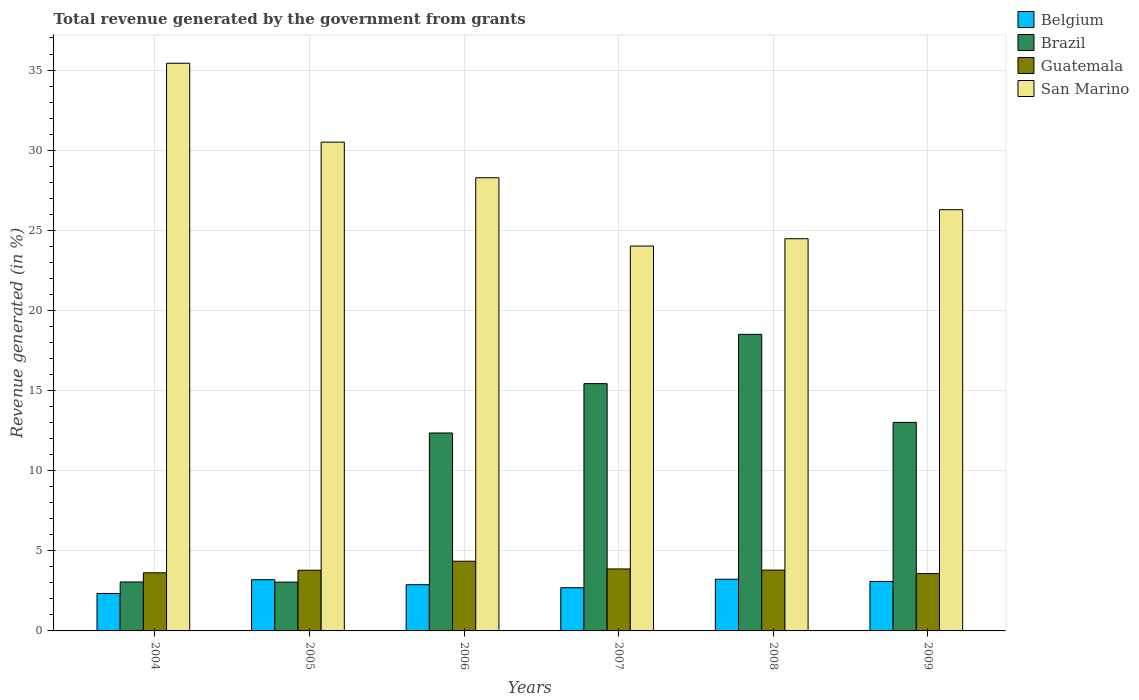How many different coloured bars are there?
Offer a very short reply. 4. Are the number of bars per tick equal to the number of legend labels?
Make the answer very short. Yes. How many bars are there on the 2nd tick from the left?
Your answer should be very brief. 4. How many bars are there on the 6th tick from the right?
Provide a short and direct response. 4. What is the label of the 6th group of bars from the left?
Your answer should be very brief. 2009. What is the total revenue generated in Brazil in 2007?
Give a very brief answer. 15.43. Across all years, what is the maximum total revenue generated in Belgium?
Make the answer very short. 3.23. Across all years, what is the minimum total revenue generated in Guatemala?
Offer a terse response. 3.58. In which year was the total revenue generated in Guatemala maximum?
Offer a very short reply. 2006. What is the total total revenue generated in Guatemala in the graph?
Your response must be concise. 23.01. What is the difference between the total revenue generated in San Marino in 2006 and that in 2008?
Your answer should be compact. 3.81. What is the difference between the total revenue generated in Belgium in 2007 and the total revenue generated in Brazil in 2008?
Offer a very short reply. -15.81. What is the average total revenue generated in Brazil per year?
Your answer should be compact. 10.9. In the year 2007, what is the difference between the total revenue generated in Guatemala and total revenue generated in Belgium?
Your answer should be compact. 1.17. In how many years, is the total revenue generated in San Marino greater than 5 %?
Provide a short and direct response. 6. What is the ratio of the total revenue generated in Belgium in 2008 to that in 2009?
Your response must be concise. 1.04. Is the difference between the total revenue generated in Guatemala in 2004 and 2008 greater than the difference between the total revenue generated in Belgium in 2004 and 2008?
Give a very brief answer. Yes. What is the difference between the highest and the second highest total revenue generated in San Marino?
Your answer should be compact. 4.92. What is the difference between the highest and the lowest total revenue generated in Brazil?
Give a very brief answer. 15.46. Is it the case that in every year, the sum of the total revenue generated in Brazil and total revenue generated in San Marino is greater than the sum of total revenue generated in Guatemala and total revenue generated in Belgium?
Your response must be concise. Yes. What does the 4th bar from the left in 2008 represents?
Offer a very short reply. San Marino. What does the 1st bar from the right in 2004 represents?
Offer a terse response. San Marino. Is it the case that in every year, the sum of the total revenue generated in Guatemala and total revenue generated in San Marino is greater than the total revenue generated in Belgium?
Offer a terse response. Yes. How many bars are there?
Give a very brief answer. 24. How many years are there in the graph?
Give a very brief answer. 6. What is the difference between two consecutive major ticks on the Y-axis?
Provide a short and direct response. 5. Does the graph contain grids?
Give a very brief answer. Yes. What is the title of the graph?
Give a very brief answer. Total revenue generated by the government from grants. Does "Sao Tome and Principe" appear as one of the legend labels in the graph?
Your answer should be compact. No. What is the label or title of the X-axis?
Offer a very short reply. Years. What is the label or title of the Y-axis?
Your answer should be compact. Revenue generated (in %). What is the Revenue generated (in %) in Belgium in 2004?
Offer a terse response. 2.34. What is the Revenue generated (in %) in Brazil in 2004?
Your response must be concise. 3.05. What is the Revenue generated (in %) of Guatemala in 2004?
Provide a short and direct response. 3.63. What is the Revenue generated (in %) of San Marino in 2004?
Make the answer very short. 35.42. What is the Revenue generated (in %) of Belgium in 2005?
Provide a short and direct response. 3.2. What is the Revenue generated (in %) in Brazil in 2005?
Your answer should be very brief. 3.04. What is the Revenue generated (in %) in Guatemala in 2005?
Offer a terse response. 3.79. What is the Revenue generated (in %) of San Marino in 2005?
Your answer should be very brief. 30.5. What is the Revenue generated (in %) in Belgium in 2006?
Make the answer very short. 2.88. What is the Revenue generated (in %) of Brazil in 2006?
Your response must be concise. 12.35. What is the Revenue generated (in %) of Guatemala in 2006?
Your response must be concise. 4.35. What is the Revenue generated (in %) of San Marino in 2006?
Your answer should be very brief. 28.28. What is the Revenue generated (in %) in Belgium in 2007?
Keep it short and to the point. 2.7. What is the Revenue generated (in %) in Brazil in 2007?
Keep it short and to the point. 15.43. What is the Revenue generated (in %) in Guatemala in 2007?
Provide a short and direct response. 3.87. What is the Revenue generated (in %) in San Marino in 2007?
Your answer should be compact. 24.02. What is the Revenue generated (in %) of Belgium in 2008?
Keep it short and to the point. 3.23. What is the Revenue generated (in %) in Brazil in 2008?
Give a very brief answer. 18.51. What is the Revenue generated (in %) in Guatemala in 2008?
Offer a terse response. 3.8. What is the Revenue generated (in %) in San Marino in 2008?
Your response must be concise. 24.47. What is the Revenue generated (in %) in Belgium in 2009?
Offer a very short reply. 3.09. What is the Revenue generated (in %) in Brazil in 2009?
Your response must be concise. 13.01. What is the Revenue generated (in %) of Guatemala in 2009?
Provide a short and direct response. 3.58. What is the Revenue generated (in %) of San Marino in 2009?
Provide a short and direct response. 26.28. Across all years, what is the maximum Revenue generated (in %) of Belgium?
Keep it short and to the point. 3.23. Across all years, what is the maximum Revenue generated (in %) of Brazil?
Your answer should be compact. 18.51. Across all years, what is the maximum Revenue generated (in %) in Guatemala?
Your response must be concise. 4.35. Across all years, what is the maximum Revenue generated (in %) in San Marino?
Provide a succinct answer. 35.42. Across all years, what is the minimum Revenue generated (in %) in Belgium?
Give a very brief answer. 2.34. Across all years, what is the minimum Revenue generated (in %) in Brazil?
Offer a terse response. 3.04. Across all years, what is the minimum Revenue generated (in %) of Guatemala?
Your answer should be compact. 3.58. Across all years, what is the minimum Revenue generated (in %) in San Marino?
Ensure brevity in your answer.  24.02. What is the total Revenue generated (in %) in Belgium in the graph?
Your answer should be very brief. 17.43. What is the total Revenue generated (in %) of Brazil in the graph?
Your response must be concise. 65.4. What is the total Revenue generated (in %) of Guatemala in the graph?
Your response must be concise. 23.01. What is the total Revenue generated (in %) of San Marino in the graph?
Make the answer very short. 168.98. What is the difference between the Revenue generated (in %) in Belgium in 2004 and that in 2005?
Provide a short and direct response. -0.86. What is the difference between the Revenue generated (in %) in Brazil in 2004 and that in 2005?
Give a very brief answer. 0.01. What is the difference between the Revenue generated (in %) in Guatemala in 2004 and that in 2005?
Your answer should be compact. -0.16. What is the difference between the Revenue generated (in %) of San Marino in 2004 and that in 2005?
Provide a succinct answer. 4.92. What is the difference between the Revenue generated (in %) of Belgium in 2004 and that in 2006?
Provide a succinct answer. -0.55. What is the difference between the Revenue generated (in %) of Brazil in 2004 and that in 2006?
Give a very brief answer. -9.3. What is the difference between the Revenue generated (in %) of Guatemala in 2004 and that in 2006?
Provide a short and direct response. -0.72. What is the difference between the Revenue generated (in %) in San Marino in 2004 and that in 2006?
Ensure brevity in your answer.  7.14. What is the difference between the Revenue generated (in %) in Belgium in 2004 and that in 2007?
Offer a very short reply. -0.36. What is the difference between the Revenue generated (in %) of Brazil in 2004 and that in 2007?
Your answer should be compact. -12.38. What is the difference between the Revenue generated (in %) of Guatemala in 2004 and that in 2007?
Make the answer very short. -0.24. What is the difference between the Revenue generated (in %) in San Marino in 2004 and that in 2007?
Your response must be concise. 11.41. What is the difference between the Revenue generated (in %) of Belgium in 2004 and that in 2008?
Provide a short and direct response. -0.89. What is the difference between the Revenue generated (in %) in Brazil in 2004 and that in 2008?
Your answer should be compact. -15.45. What is the difference between the Revenue generated (in %) in Guatemala in 2004 and that in 2008?
Your answer should be very brief. -0.17. What is the difference between the Revenue generated (in %) in San Marino in 2004 and that in 2008?
Make the answer very short. 10.95. What is the difference between the Revenue generated (in %) in Belgium in 2004 and that in 2009?
Keep it short and to the point. -0.75. What is the difference between the Revenue generated (in %) in Brazil in 2004 and that in 2009?
Ensure brevity in your answer.  -9.96. What is the difference between the Revenue generated (in %) in Guatemala in 2004 and that in 2009?
Your answer should be very brief. 0.05. What is the difference between the Revenue generated (in %) in San Marino in 2004 and that in 2009?
Give a very brief answer. 9.14. What is the difference between the Revenue generated (in %) of Belgium in 2005 and that in 2006?
Offer a very short reply. 0.31. What is the difference between the Revenue generated (in %) of Brazil in 2005 and that in 2006?
Provide a succinct answer. -9.31. What is the difference between the Revenue generated (in %) of Guatemala in 2005 and that in 2006?
Your answer should be very brief. -0.56. What is the difference between the Revenue generated (in %) of San Marino in 2005 and that in 2006?
Keep it short and to the point. 2.22. What is the difference between the Revenue generated (in %) in Belgium in 2005 and that in 2007?
Provide a succinct answer. 0.5. What is the difference between the Revenue generated (in %) of Brazil in 2005 and that in 2007?
Your response must be concise. -12.39. What is the difference between the Revenue generated (in %) in Guatemala in 2005 and that in 2007?
Your response must be concise. -0.08. What is the difference between the Revenue generated (in %) of San Marino in 2005 and that in 2007?
Ensure brevity in your answer.  6.49. What is the difference between the Revenue generated (in %) of Belgium in 2005 and that in 2008?
Provide a succinct answer. -0.03. What is the difference between the Revenue generated (in %) of Brazil in 2005 and that in 2008?
Your answer should be very brief. -15.46. What is the difference between the Revenue generated (in %) of Guatemala in 2005 and that in 2008?
Provide a succinct answer. -0.01. What is the difference between the Revenue generated (in %) in San Marino in 2005 and that in 2008?
Make the answer very short. 6.03. What is the difference between the Revenue generated (in %) in Belgium in 2005 and that in 2009?
Ensure brevity in your answer.  0.11. What is the difference between the Revenue generated (in %) in Brazil in 2005 and that in 2009?
Offer a very short reply. -9.97. What is the difference between the Revenue generated (in %) of Guatemala in 2005 and that in 2009?
Offer a terse response. 0.21. What is the difference between the Revenue generated (in %) of San Marino in 2005 and that in 2009?
Keep it short and to the point. 4.22. What is the difference between the Revenue generated (in %) of Belgium in 2006 and that in 2007?
Your answer should be very brief. 0.19. What is the difference between the Revenue generated (in %) in Brazil in 2006 and that in 2007?
Provide a succinct answer. -3.08. What is the difference between the Revenue generated (in %) in Guatemala in 2006 and that in 2007?
Provide a succinct answer. 0.48. What is the difference between the Revenue generated (in %) in San Marino in 2006 and that in 2007?
Make the answer very short. 4.26. What is the difference between the Revenue generated (in %) in Belgium in 2006 and that in 2008?
Your answer should be compact. -0.34. What is the difference between the Revenue generated (in %) in Brazil in 2006 and that in 2008?
Your answer should be very brief. -6.16. What is the difference between the Revenue generated (in %) of Guatemala in 2006 and that in 2008?
Provide a succinct answer. 0.55. What is the difference between the Revenue generated (in %) of San Marino in 2006 and that in 2008?
Provide a succinct answer. 3.81. What is the difference between the Revenue generated (in %) of Belgium in 2006 and that in 2009?
Your answer should be very brief. -0.2. What is the difference between the Revenue generated (in %) in Brazil in 2006 and that in 2009?
Keep it short and to the point. -0.66. What is the difference between the Revenue generated (in %) in Guatemala in 2006 and that in 2009?
Your answer should be very brief. 0.77. What is the difference between the Revenue generated (in %) in San Marino in 2006 and that in 2009?
Your answer should be compact. 1.99. What is the difference between the Revenue generated (in %) of Belgium in 2007 and that in 2008?
Provide a short and direct response. -0.53. What is the difference between the Revenue generated (in %) in Brazil in 2007 and that in 2008?
Your response must be concise. -3.08. What is the difference between the Revenue generated (in %) in Guatemala in 2007 and that in 2008?
Provide a succinct answer. 0.07. What is the difference between the Revenue generated (in %) in San Marino in 2007 and that in 2008?
Give a very brief answer. -0.46. What is the difference between the Revenue generated (in %) of Belgium in 2007 and that in 2009?
Ensure brevity in your answer.  -0.39. What is the difference between the Revenue generated (in %) of Brazil in 2007 and that in 2009?
Your answer should be compact. 2.42. What is the difference between the Revenue generated (in %) in Guatemala in 2007 and that in 2009?
Offer a very short reply. 0.29. What is the difference between the Revenue generated (in %) of San Marino in 2007 and that in 2009?
Offer a terse response. -2.27. What is the difference between the Revenue generated (in %) of Belgium in 2008 and that in 2009?
Ensure brevity in your answer.  0.14. What is the difference between the Revenue generated (in %) of Brazil in 2008 and that in 2009?
Your response must be concise. 5.5. What is the difference between the Revenue generated (in %) of Guatemala in 2008 and that in 2009?
Provide a succinct answer. 0.22. What is the difference between the Revenue generated (in %) of San Marino in 2008 and that in 2009?
Offer a terse response. -1.81. What is the difference between the Revenue generated (in %) in Belgium in 2004 and the Revenue generated (in %) in Brazil in 2005?
Give a very brief answer. -0.71. What is the difference between the Revenue generated (in %) in Belgium in 2004 and the Revenue generated (in %) in Guatemala in 2005?
Make the answer very short. -1.45. What is the difference between the Revenue generated (in %) of Belgium in 2004 and the Revenue generated (in %) of San Marino in 2005?
Make the answer very short. -28.16. What is the difference between the Revenue generated (in %) in Brazil in 2004 and the Revenue generated (in %) in Guatemala in 2005?
Your response must be concise. -0.73. What is the difference between the Revenue generated (in %) in Brazil in 2004 and the Revenue generated (in %) in San Marino in 2005?
Give a very brief answer. -27.45. What is the difference between the Revenue generated (in %) of Guatemala in 2004 and the Revenue generated (in %) of San Marino in 2005?
Offer a very short reply. -26.87. What is the difference between the Revenue generated (in %) in Belgium in 2004 and the Revenue generated (in %) in Brazil in 2006?
Provide a succinct answer. -10.01. What is the difference between the Revenue generated (in %) in Belgium in 2004 and the Revenue generated (in %) in Guatemala in 2006?
Keep it short and to the point. -2.01. What is the difference between the Revenue generated (in %) in Belgium in 2004 and the Revenue generated (in %) in San Marino in 2006?
Offer a very short reply. -25.94. What is the difference between the Revenue generated (in %) of Brazil in 2004 and the Revenue generated (in %) of Guatemala in 2006?
Your answer should be compact. -1.3. What is the difference between the Revenue generated (in %) of Brazil in 2004 and the Revenue generated (in %) of San Marino in 2006?
Give a very brief answer. -25.22. What is the difference between the Revenue generated (in %) of Guatemala in 2004 and the Revenue generated (in %) of San Marino in 2006?
Offer a very short reply. -24.65. What is the difference between the Revenue generated (in %) of Belgium in 2004 and the Revenue generated (in %) of Brazil in 2007?
Your response must be concise. -13.09. What is the difference between the Revenue generated (in %) in Belgium in 2004 and the Revenue generated (in %) in Guatemala in 2007?
Your answer should be compact. -1.53. What is the difference between the Revenue generated (in %) of Belgium in 2004 and the Revenue generated (in %) of San Marino in 2007?
Offer a terse response. -21.68. What is the difference between the Revenue generated (in %) in Brazil in 2004 and the Revenue generated (in %) in Guatemala in 2007?
Make the answer very short. -0.81. What is the difference between the Revenue generated (in %) in Brazil in 2004 and the Revenue generated (in %) in San Marino in 2007?
Ensure brevity in your answer.  -20.96. What is the difference between the Revenue generated (in %) in Guatemala in 2004 and the Revenue generated (in %) in San Marino in 2007?
Provide a succinct answer. -20.39. What is the difference between the Revenue generated (in %) of Belgium in 2004 and the Revenue generated (in %) of Brazil in 2008?
Your response must be concise. -16.17. What is the difference between the Revenue generated (in %) in Belgium in 2004 and the Revenue generated (in %) in Guatemala in 2008?
Offer a very short reply. -1.46. What is the difference between the Revenue generated (in %) in Belgium in 2004 and the Revenue generated (in %) in San Marino in 2008?
Ensure brevity in your answer.  -22.14. What is the difference between the Revenue generated (in %) in Brazil in 2004 and the Revenue generated (in %) in Guatemala in 2008?
Give a very brief answer. -0.74. What is the difference between the Revenue generated (in %) of Brazil in 2004 and the Revenue generated (in %) of San Marino in 2008?
Your answer should be very brief. -21.42. What is the difference between the Revenue generated (in %) of Guatemala in 2004 and the Revenue generated (in %) of San Marino in 2008?
Provide a succinct answer. -20.85. What is the difference between the Revenue generated (in %) of Belgium in 2004 and the Revenue generated (in %) of Brazil in 2009?
Make the answer very short. -10.68. What is the difference between the Revenue generated (in %) in Belgium in 2004 and the Revenue generated (in %) in Guatemala in 2009?
Provide a short and direct response. -1.24. What is the difference between the Revenue generated (in %) of Belgium in 2004 and the Revenue generated (in %) of San Marino in 2009?
Your answer should be very brief. -23.95. What is the difference between the Revenue generated (in %) of Brazil in 2004 and the Revenue generated (in %) of Guatemala in 2009?
Make the answer very short. -0.53. What is the difference between the Revenue generated (in %) of Brazil in 2004 and the Revenue generated (in %) of San Marino in 2009?
Your answer should be compact. -23.23. What is the difference between the Revenue generated (in %) of Guatemala in 2004 and the Revenue generated (in %) of San Marino in 2009?
Provide a succinct answer. -22.66. What is the difference between the Revenue generated (in %) of Belgium in 2005 and the Revenue generated (in %) of Brazil in 2006?
Provide a succinct answer. -9.15. What is the difference between the Revenue generated (in %) of Belgium in 2005 and the Revenue generated (in %) of Guatemala in 2006?
Keep it short and to the point. -1.15. What is the difference between the Revenue generated (in %) in Belgium in 2005 and the Revenue generated (in %) in San Marino in 2006?
Offer a very short reply. -25.08. What is the difference between the Revenue generated (in %) of Brazil in 2005 and the Revenue generated (in %) of Guatemala in 2006?
Keep it short and to the point. -1.31. What is the difference between the Revenue generated (in %) in Brazil in 2005 and the Revenue generated (in %) in San Marino in 2006?
Make the answer very short. -25.23. What is the difference between the Revenue generated (in %) in Guatemala in 2005 and the Revenue generated (in %) in San Marino in 2006?
Ensure brevity in your answer.  -24.49. What is the difference between the Revenue generated (in %) of Belgium in 2005 and the Revenue generated (in %) of Brazil in 2007?
Provide a succinct answer. -12.23. What is the difference between the Revenue generated (in %) of Belgium in 2005 and the Revenue generated (in %) of Guatemala in 2007?
Your answer should be compact. -0.67. What is the difference between the Revenue generated (in %) of Belgium in 2005 and the Revenue generated (in %) of San Marino in 2007?
Make the answer very short. -20.82. What is the difference between the Revenue generated (in %) of Brazil in 2005 and the Revenue generated (in %) of Guatemala in 2007?
Your answer should be compact. -0.82. What is the difference between the Revenue generated (in %) in Brazil in 2005 and the Revenue generated (in %) in San Marino in 2007?
Provide a succinct answer. -20.97. What is the difference between the Revenue generated (in %) in Guatemala in 2005 and the Revenue generated (in %) in San Marino in 2007?
Your response must be concise. -20.23. What is the difference between the Revenue generated (in %) of Belgium in 2005 and the Revenue generated (in %) of Brazil in 2008?
Keep it short and to the point. -15.31. What is the difference between the Revenue generated (in %) in Belgium in 2005 and the Revenue generated (in %) in Guatemala in 2008?
Your response must be concise. -0.6. What is the difference between the Revenue generated (in %) of Belgium in 2005 and the Revenue generated (in %) of San Marino in 2008?
Make the answer very short. -21.28. What is the difference between the Revenue generated (in %) in Brazil in 2005 and the Revenue generated (in %) in Guatemala in 2008?
Ensure brevity in your answer.  -0.75. What is the difference between the Revenue generated (in %) of Brazil in 2005 and the Revenue generated (in %) of San Marino in 2008?
Provide a short and direct response. -21.43. What is the difference between the Revenue generated (in %) of Guatemala in 2005 and the Revenue generated (in %) of San Marino in 2008?
Offer a terse response. -20.69. What is the difference between the Revenue generated (in %) of Belgium in 2005 and the Revenue generated (in %) of Brazil in 2009?
Offer a very short reply. -9.82. What is the difference between the Revenue generated (in %) in Belgium in 2005 and the Revenue generated (in %) in Guatemala in 2009?
Your answer should be compact. -0.38. What is the difference between the Revenue generated (in %) in Belgium in 2005 and the Revenue generated (in %) in San Marino in 2009?
Offer a terse response. -23.09. What is the difference between the Revenue generated (in %) of Brazil in 2005 and the Revenue generated (in %) of Guatemala in 2009?
Provide a short and direct response. -0.54. What is the difference between the Revenue generated (in %) in Brazil in 2005 and the Revenue generated (in %) in San Marino in 2009?
Offer a terse response. -23.24. What is the difference between the Revenue generated (in %) of Guatemala in 2005 and the Revenue generated (in %) of San Marino in 2009?
Make the answer very short. -22.5. What is the difference between the Revenue generated (in %) of Belgium in 2006 and the Revenue generated (in %) of Brazil in 2007?
Provide a short and direct response. -12.55. What is the difference between the Revenue generated (in %) of Belgium in 2006 and the Revenue generated (in %) of Guatemala in 2007?
Give a very brief answer. -0.98. What is the difference between the Revenue generated (in %) of Belgium in 2006 and the Revenue generated (in %) of San Marino in 2007?
Provide a short and direct response. -21.13. What is the difference between the Revenue generated (in %) of Brazil in 2006 and the Revenue generated (in %) of Guatemala in 2007?
Provide a short and direct response. 8.48. What is the difference between the Revenue generated (in %) of Brazil in 2006 and the Revenue generated (in %) of San Marino in 2007?
Offer a terse response. -11.66. What is the difference between the Revenue generated (in %) in Guatemala in 2006 and the Revenue generated (in %) in San Marino in 2007?
Your answer should be compact. -19.67. What is the difference between the Revenue generated (in %) of Belgium in 2006 and the Revenue generated (in %) of Brazil in 2008?
Your answer should be compact. -15.62. What is the difference between the Revenue generated (in %) in Belgium in 2006 and the Revenue generated (in %) in Guatemala in 2008?
Keep it short and to the point. -0.91. What is the difference between the Revenue generated (in %) in Belgium in 2006 and the Revenue generated (in %) in San Marino in 2008?
Give a very brief answer. -21.59. What is the difference between the Revenue generated (in %) of Brazil in 2006 and the Revenue generated (in %) of Guatemala in 2008?
Provide a succinct answer. 8.55. What is the difference between the Revenue generated (in %) of Brazil in 2006 and the Revenue generated (in %) of San Marino in 2008?
Offer a terse response. -12.12. What is the difference between the Revenue generated (in %) in Guatemala in 2006 and the Revenue generated (in %) in San Marino in 2008?
Offer a terse response. -20.12. What is the difference between the Revenue generated (in %) of Belgium in 2006 and the Revenue generated (in %) of Brazil in 2009?
Offer a terse response. -10.13. What is the difference between the Revenue generated (in %) in Belgium in 2006 and the Revenue generated (in %) in Guatemala in 2009?
Offer a very short reply. -0.7. What is the difference between the Revenue generated (in %) of Belgium in 2006 and the Revenue generated (in %) of San Marino in 2009?
Your answer should be compact. -23.4. What is the difference between the Revenue generated (in %) of Brazil in 2006 and the Revenue generated (in %) of Guatemala in 2009?
Your answer should be compact. 8.77. What is the difference between the Revenue generated (in %) in Brazil in 2006 and the Revenue generated (in %) in San Marino in 2009?
Your answer should be compact. -13.93. What is the difference between the Revenue generated (in %) in Guatemala in 2006 and the Revenue generated (in %) in San Marino in 2009?
Offer a terse response. -21.94. What is the difference between the Revenue generated (in %) in Belgium in 2007 and the Revenue generated (in %) in Brazil in 2008?
Give a very brief answer. -15.81. What is the difference between the Revenue generated (in %) in Belgium in 2007 and the Revenue generated (in %) in Guatemala in 2008?
Make the answer very short. -1.1. What is the difference between the Revenue generated (in %) in Belgium in 2007 and the Revenue generated (in %) in San Marino in 2008?
Provide a succinct answer. -21.78. What is the difference between the Revenue generated (in %) of Brazil in 2007 and the Revenue generated (in %) of Guatemala in 2008?
Provide a short and direct response. 11.63. What is the difference between the Revenue generated (in %) in Brazil in 2007 and the Revenue generated (in %) in San Marino in 2008?
Offer a very short reply. -9.04. What is the difference between the Revenue generated (in %) in Guatemala in 2007 and the Revenue generated (in %) in San Marino in 2008?
Provide a short and direct response. -20.61. What is the difference between the Revenue generated (in %) in Belgium in 2007 and the Revenue generated (in %) in Brazil in 2009?
Provide a short and direct response. -10.32. What is the difference between the Revenue generated (in %) in Belgium in 2007 and the Revenue generated (in %) in Guatemala in 2009?
Ensure brevity in your answer.  -0.88. What is the difference between the Revenue generated (in %) of Belgium in 2007 and the Revenue generated (in %) of San Marino in 2009?
Provide a short and direct response. -23.59. What is the difference between the Revenue generated (in %) in Brazil in 2007 and the Revenue generated (in %) in Guatemala in 2009?
Your response must be concise. 11.85. What is the difference between the Revenue generated (in %) in Brazil in 2007 and the Revenue generated (in %) in San Marino in 2009?
Your response must be concise. -10.85. What is the difference between the Revenue generated (in %) in Guatemala in 2007 and the Revenue generated (in %) in San Marino in 2009?
Provide a succinct answer. -22.42. What is the difference between the Revenue generated (in %) of Belgium in 2008 and the Revenue generated (in %) of Brazil in 2009?
Your answer should be compact. -9.79. What is the difference between the Revenue generated (in %) in Belgium in 2008 and the Revenue generated (in %) in Guatemala in 2009?
Make the answer very short. -0.35. What is the difference between the Revenue generated (in %) in Belgium in 2008 and the Revenue generated (in %) in San Marino in 2009?
Your answer should be compact. -23.06. What is the difference between the Revenue generated (in %) of Brazil in 2008 and the Revenue generated (in %) of Guatemala in 2009?
Keep it short and to the point. 14.93. What is the difference between the Revenue generated (in %) in Brazil in 2008 and the Revenue generated (in %) in San Marino in 2009?
Keep it short and to the point. -7.78. What is the difference between the Revenue generated (in %) of Guatemala in 2008 and the Revenue generated (in %) of San Marino in 2009?
Provide a succinct answer. -22.49. What is the average Revenue generated (in %) of Belgium per year?
Your answer should be compact. 2.9. What is the average Revenue generated (in %) in Brazil per year?
Offer a very short reply. 10.9. What is the average Revenue generated (in %) in Guatemala per year?
Your response must be concise. 3.83. What is the average Revenue generated (in %) of San Marino per year?
Ensure brevity in your answer.  28.16. In the year 2004, what is the difference between the Revenue generated (in %) of Belgium and Revenue generated (in %) of Brazil?
Give a very brief answer. -0.72. In the year 2004, what is the difference between the Revenue generated (in %) of Belgium and Revenue generated (in %) of Guatemala?
Give a very brief answer. -1.29. In the year 2004, what is the difference between the Revenue generated (in %) of Belgium and Revenue generated (in %) of San Marino?
Offer a very short reply. -33.09. In the year 2004, what is the difference between the Revenue generated (in %) in Brazil and Revenue generated (in %) in Guatemala?
Ensure brevity in your answer.  -0.57. In the year 2004, what is the difference between the Revenue generated (in %) of Brazil and Revenue generated (in %) of San Marino?
Keep it short and to the point. -32.37. In the year 2004, what is the difference between the Revenue generated (in %) of Guatemala and Revenue generated (in %) of San Marino?
Your answer should be very brief. -31.8. In the year 2005, what is the difference between the Revenue generated (in %) of Belgium and Revenue generated (in %) of Brazil?
Your response must be concise. 0.15. In the year 2005, what is the difference between the Revenue generated (in %) of Belgium and Revenue generated (in %) of Guatemala?
Provide a succinct answer. -0.59. In the year 2005, what is the difference between the Revenue generated (in %) in Belgium and Revenue generated (in %) in San Marino?
Offer a very short reply. -27.3. In the year 2005, what is the difference between the Revenue generated (in %) of Brazil and Revenue generated (in %) of Guatemala?
Your answer should be compact. -0.74. In the year 2005, what is the difference between the Revenue generated (in %) in Brazil and Revenue generated (in %) in San Marino?
Offer a very short reply. -27.46. In the year 2005, what is the difference between the Revenue generated (in %) of Guatemala and Revenue generated (in %) of San Marino?
Your response must be concise. -26.71. In the year 2006, what is the difference between the Revenue generated (in %) in Belgium and Revenue generated (in %) in Brazil?
Your response must be concise. -9.47. In the year 2006, what is the difference between the Revenue generated (in %) in Belgium and Revenue generated (in %) in Guatemala?
Provide a succinct answer. -1.47. In the year 2006, what is the difference between the Revenue generated (in %) in Belgium and Revenue generated (in %) in San Marino?
Provide a succinct answer. -25.39. In the year 2006, what is the difference between the Revenue generated (in %) in Brazil and Revenue generated (in %) in Guatemala?
Provide a short and direct response. 8. In the year 2006, what is the difference between the Revenue generated (in %) in Brazil and Revenue generated (in %) in San Marino?
Ensure brevity in your answer.  -15.93. In the year 2006, what is the difference between the Revenue generated (in %) in Guatemala and Revenue generated (in %) in San Marino?
Your answer should be very brief. -23.93. In the year 2007, what is the difference between the Revenue generated (in %) of Belgium and Revenue generated (in %) of Brazil?
Your response must be concise. -12.74. In the year 2007, what is the difference between the Revenue generated (in %) in Belgium and Revenue generated (in %) in Guatemala?
Your response must be concise. -1.17. In the year 2007, what is the difference between the Revenue generated (in %) in Belgium and Revenue generated (in %) in San Marino?
Make the answer very short. -21.32. In the year 2007, what is the difference between the Revenue generated (in %) in Brazil and Revenue generated (in %) in Guatemala?
Your answer should be very brief. 11.56. In the year 2007, what is the difference between the Revenue generated (in %) of Brazil and Revenue generated (in %) of San Marino?
Your answer should be very brief. -8.58. In the year 2007, what is the difference between the Revenue generated (in %) in Guatemala and Revenue generated (in %) in San Marino?
Your answer should be compact. -20.15. In the year 2008, what is the difference between the Revenue generated (in %) in Belgium and Revenue generated (in %) in Brazil?
Your answer should be very brief. -15.28. In the year 2008, what is the difference between the Revenue generated (in %) of Belgium and Revenue generated (in %) of Guatemala?
Keep it short and to the point. -0.57. In the year 2008, what is the difference between the Revenue generated (in %) of Belgium and Revenue generated (in %) of San Marino?
Offer a very short reply. -21.25. In the year 2008, what is the difference between the Revenue generated (in %) in Brazil and Revenue generated (in %) in Guatemala?
Keep it short and to the point. 14.71. In the year 2008, what is the difference between the Revenue generated (in %) of Brazil and Revenue generated (in %) of San Marino?
Your answer should be compact. -5.97. In the year 2008, what is the difference between the Revenue generated (in %) in Guatemala and Revenue generated (in %) in San Marino?
Make the answer very short. -20.68. In the year 2009, what is the difference between the Revenue generated (in %) in Belgium and Revenue generated (in %) in Brazil?
Provide a short and direct response. -9.92. In the year 2009, what is the difference between the Revenue generated (in %) in Belgium and Revenue generated (in %) in Guatemala?
Provide a short and direct response. -0.49. In the year 2009, what is the difference between the Revenue generated (in %) of Belgium and Revenue generated (in %) of San Marino?
Your answer should be compact. -23.2. In the year 2009, what is the difference between the Revenue generated (in %) of Brazil and Revenue generated (in %) of Guatemala?
Offer a terse response. 9.43. In the year 2009, what is the difference between the Revenue generated (in %) in Brazil and Revenue generated (in %) in San Marino?
Give a very brief answer. -13.27. In the year 2009, what is the difference between the Revenue generated (in %) in Guatemala and Revenue generated (in %) in San Marino?
Provide a short and direct response. -22.7. What is the ratio of the Revenue generated (in %) in Belgium in 2004 to that in 2005?
Your answer should be compact. 0.73. What is the ratio of the Revenue generated (in %) in Guatemala in 2004 to that in 2005?
Your answer should be compact. 0.96. What is the ratio of the Revenue generated (in %) of San Marino in 2004 to that in 2005?
Your answer should be compact. 1.16. What is the ratio of the Revenue generated (in %) in Belgium in 2004 to that in 2006?
Give a very brief answer. 0.81. What is the ratio of the Revenue generated (in %) in Brazil in 2004 to that in 2006?
Your answer should be compact. 0.25. What is the ratio of the Revenue generated (in %) in Guatemala in 2004 to that in 2006?
Provide a short and direct response. 0.83. What is the ratio of the Revenue generated (in %) of San Marino in 2004 to that in 2006?
Offer a very short reply. 1.25. What is the ratio of the Revenue generated (in %) in Belgium in 2004 to that in 2007?
Offer a terse response. 0.87. What is the ratio of the Revenue generated (in %) of Brazil in 2004 to that in 2007?
Your answer should be very brief. 0.2. What is the ratio of the Revenue generated (in %) in Guatemala in 2004 to that in 2007?
Make the answer very short. 0.94. What is the ratio of the Revenue generated (in %) of San Marino in 2004 to that in 2007?
Your answer should be very brief. 1.48. What is the ratio of the Revenue generated (in %) in Belgium in 2004 to that in 2008?
Your response must be concise. 0.72. What is the ratio of the Revenue generated (in %) in Brazil in 2004 to that in 2008?
Your answer should be very brief. 0.17. What is the ratio of the Revenue generated (in %) in Guatemala in 2004 to that in 2008?
Provide a succinct answer. 0.96. What is the ratio of the Revenue generated (in %) in San Marino in 2004 to that in 2008?
Your response must be concise. 1.45. What is the ratio of the Revenue generated (in %) of Belgium in 2004 to that in 2009?
Provide a succinct answer. 0.76. What is the ratio of the Revenue generated (in %) in Brazil in 2004 to that in 2009?
Offer a terse response. 0.23. What is the ratio of the Revenue generated (in %) in Guatemala in 2004 to that in 2009?
Offer a very short reply. 1.01. What is the ratio of the Revenue generated (in %) of San Marino in 2004 to that in 2009?
Offer a very short reply. 1.35. What is the ratio of the Revenue generated (in %) in Belgium in 2005 to that in 2006?
Offer a very short reply. 1.11. What is the ratio of the Revenue generated (in %) of Brazil in 2005 to that in 2006?
Give a very brief answer. 0.25. What is the ratio of the Revenue generated (in %) of Guatemala in 2005 to that in 2006?
Your response must be concise. 0.87. What is the ratio of the Revenue generated (in %) of San Marino in 2005 to that in 2006?
Your answer should be very brief. 1.08. What is the ratio of the Revenue generated (in %) in Belgium in 2005 to that in 2007?
Provide a succinct answer. 1.19. What is the ratio of the Revenue generated (in %) of Brazil in 2005 to that in 2007?
Provide a succinct answer. 0.2. What is the ratio of the Revenue generated (in %) in Guatemala in 2005 to that in 2007?
Provide a short and direct response. 0.98. What is the ratio of the Revenue generated (in %) in San Marino in 2005 to that in 2007?
Make the answer very short. 1.27. What is the ratio of the Revenue generated (in %) of Brazil in 2005 to that in 2008?
Make the answer very short. 0.16. What is the ratio of the Revenue generated (in %) in San Marino in 2005 to that in 2008?
Ensure brevity in your answer.  1.25. What is the ratio of the Revenue generated (in %) in Belgium in 2005 to that in 2009?
Provide a succinct answer. 1.04. What is the ratio of the Revenue generated (in %) of Brazil in 2005 to that in 2009?
Give a very brief answer. 0.23. What is the ratio of the Revenue generated (in %) of Guatemala in 2005 to that in 2009?
Ensure brevity in your answer.  1.06. What is the ratio of the Revenue generated (in %) of San Marino in 2005 to that in 2009?
Offer a very short reply. 1.16. What is the ratio of the Revenue generated (in %) of Belgium in 2006 to that in 2007?
Make the answer very short. 1.07. What is the ratio of the Revenue generated (in %) of Brazil in 2006 to that in 2007?
Offer a very short reply. 0.8. What is the ratio of the Revenue generated (in %) of Guatemala in 2006 to that in 2007?
Your response must be concise. 1.12. What is the ratio of the Revenue generated (in %) in San Marino in 2006 to that in 2007?
Your answer should be compact. 1.18. What is the ratio of the Revenue generated (in %) of Belgium in 2006 to that in 2008?
Make the answer very short. 0.89. What is the ratio of the Revenue generated (in %) in Brazil in 2006 to that in 2008?
Provide a succinct answer. 0.67. What is the ratio of the Revenue generated (in %) of Guatemala in 2006 to that in 2008?
Your response must be concise. 1.15. What is the ratio of the Revenue generated (in %) in San Marino in 2006 to that in 2008?
Ensure brevity in your answer.  1.16. What is the ratio of the Revenue generated (in %) of Belgium in 2006 to that in 2009?
Offer a very short reply. 0.93. What is the ratio of the Revenue generated (in %) in Brazil in 2006 to that in 2009?
Keep it short and to the point. 0.95. What is the ratio of the Revenue generated (in %) of Guatemala in 2006 to that in 2009?
Offer a terse response. 1.21. What is the ratio of the Revenue generated (in %) in San Marino in 2006 to that in 2009?
Offer a terse response. 1.08. What is the ratio of the Revenue generated (in %) in Belgium in 2007 to that in 2008?
Your answer should be compact. 0.84. What is the ratio of the Revenue generated (in %) of Brazil in 2007 to that in 2008?
Provide a succinct answer. 0.83. What is the ratio of the Revenue generated (in %) in Guatemala in 2007 to that in 2008?
Your answer should be compact. 1.02. What is the ratio of the Revenue generated (in %) of San Marino in 2007 to that in 2008?
Keep it short and to the point. 0.98. What is the ratio of the Revenue generated (in %) of Belgium in 2007 to that in 2009?
Your answer should be compact. 0.87. What is the ratio of the Revenue generated (in %) in Brazil in 2007 to that in 2009?
Your answer should be compact. 1.19. What is the ratio of the Revenue generated (in %) of Guatemala in 2007 to that in 2009?
Give a very brief answer. 1.08. What is the ratio of the Revenue generated (in %) of San Marino in 2007 to that in 2009?
Make the answer very short. 0.91. What is the ratio of the Revenue generated (in %) of Belgium in 2008 to that in 2009?
Give a very brief answer. 1.04. What is the ratio of the Revenue generated (in %) in Brazil in 2008 to that in 2009?
Provide a succinct answer. 1.42. What is the ratio of the Revenue generated (in %) of Guatemala in 2008 to that in 2009?
Your response must be concise. 1.06. What is the ratio of the Revenue generated (in %) in San Marino in 2008 to that in 2009?
Ensure brevity in your answer.  0.93. What is the difference between the highest and the second highest Revenue generated (in %) in Belgium?
Ensure brevity in your answer.  0.03. What is the difference between the highest and the second highest Revenue generated (in %) of Brazil?
Offer a terse response. 3.08. What is the difference between the highest and the second highest Revenue generated (in %) in Guatemala?
Ensure brevity in your answer.  0.48. What is the difference between the highest and the second highest Revenue generated (in %) in San Marino?
Your answer should be compact. 4.92. What is the difference between the highest and the lowest Revenue generated (in %) in Belgium?
Keep it short and to the point. 0.89. What is the difference between the highest and the lowest Revenue generated (in %) of Brazil?
Your response must be concise. 15.46. What is the difference between the highest and the lowest Revenue generated (in %) in Guatemala?
Your answer should be compact. 0.77. What is the difference between the highest and the lowest Revenue generated (in %) of San Marino?
Provide a succinct answer. 11.41. 